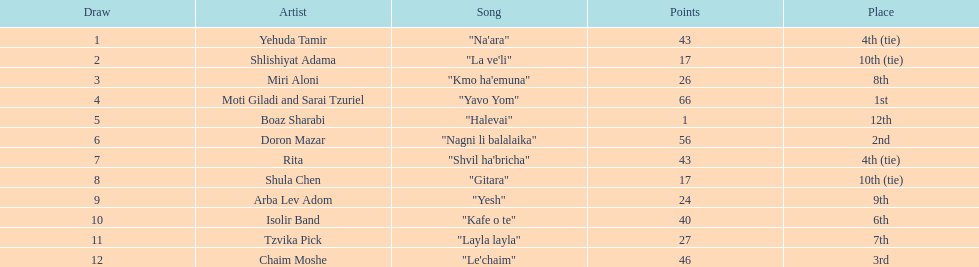How many artists are there? Yehuda Tamir, Shlishiyat Adama, Miri Aloni, Moti Giladi and Sarai Tzuriel, Boaz Sharabi, Doron Mazar, Rita, Shula Chen, Arba Lev Adom, Isolir Band, Tzvika Pick, Chaim Moshe. What is the least amount of points awarded? 1. Who was the artist awarded those points? Boaz Sharabi. 